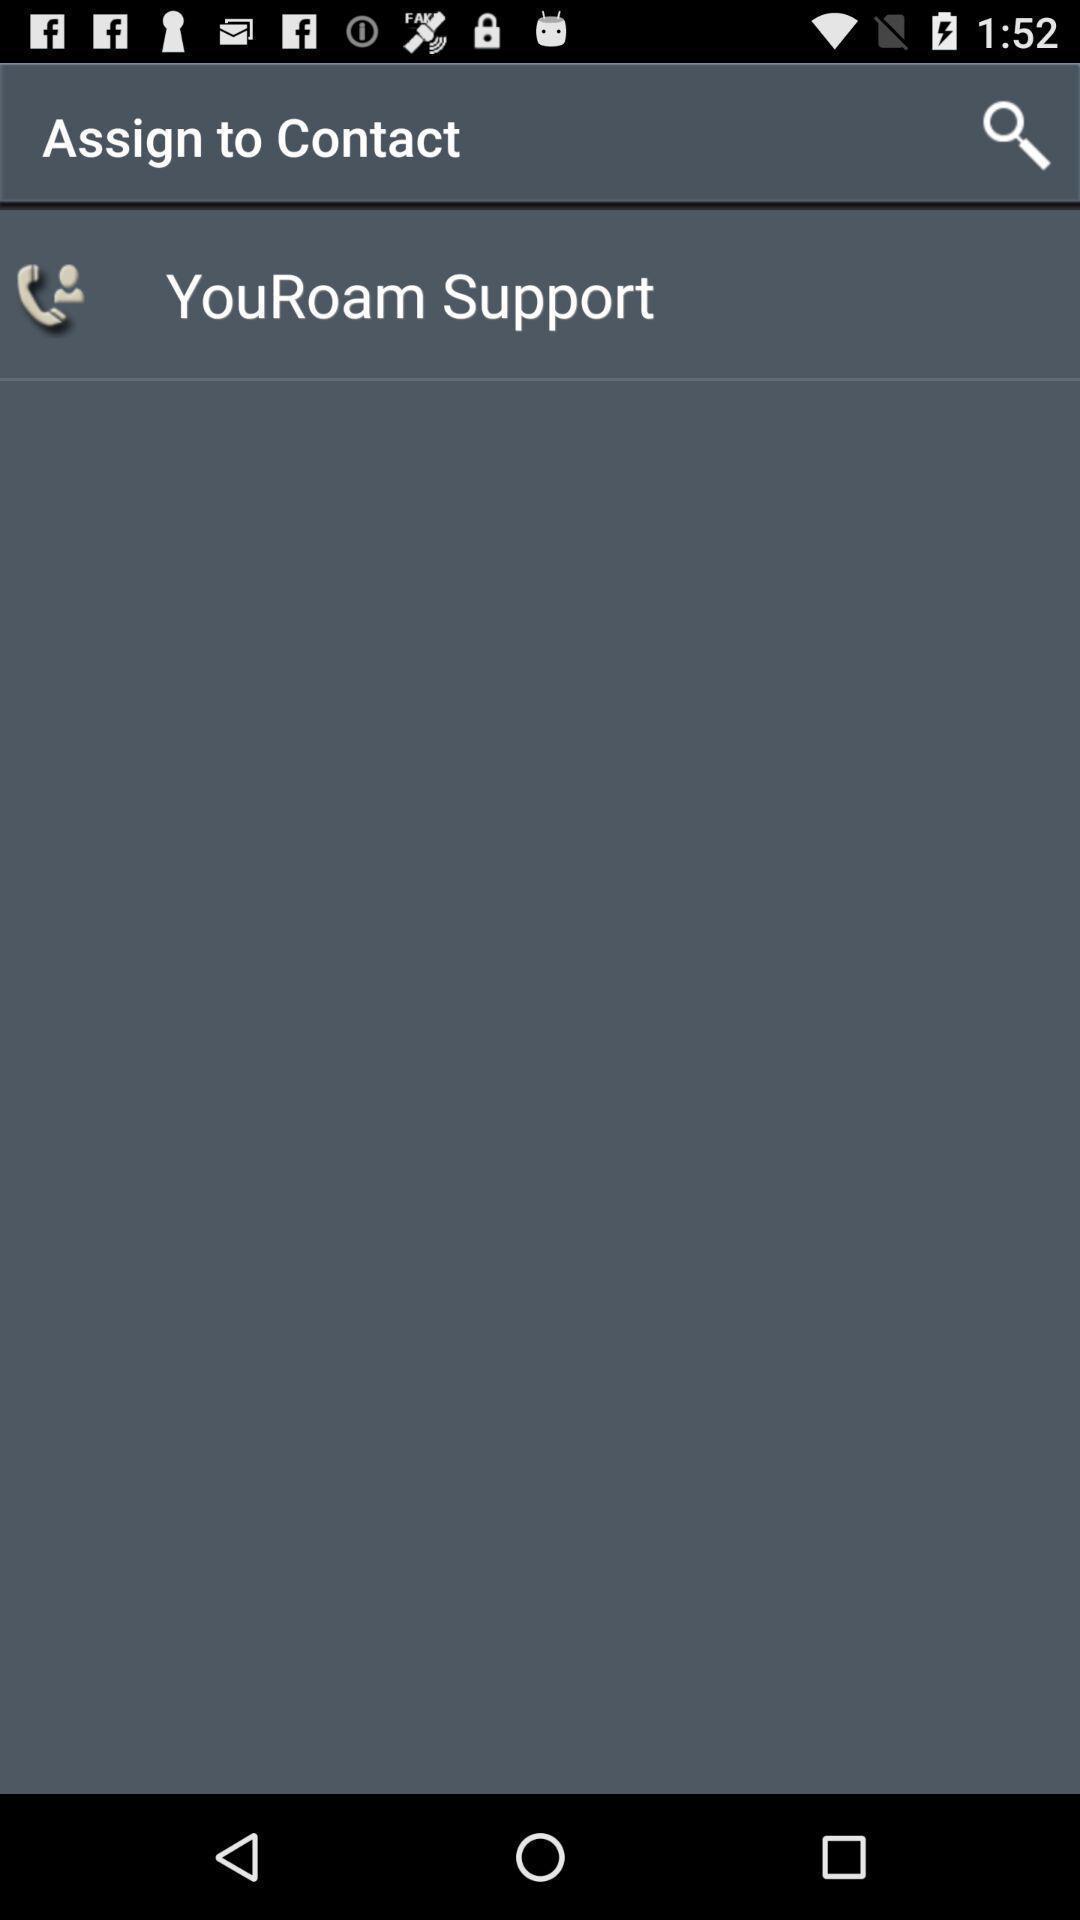What details can you identify in this image? Page showing information about contacts. 